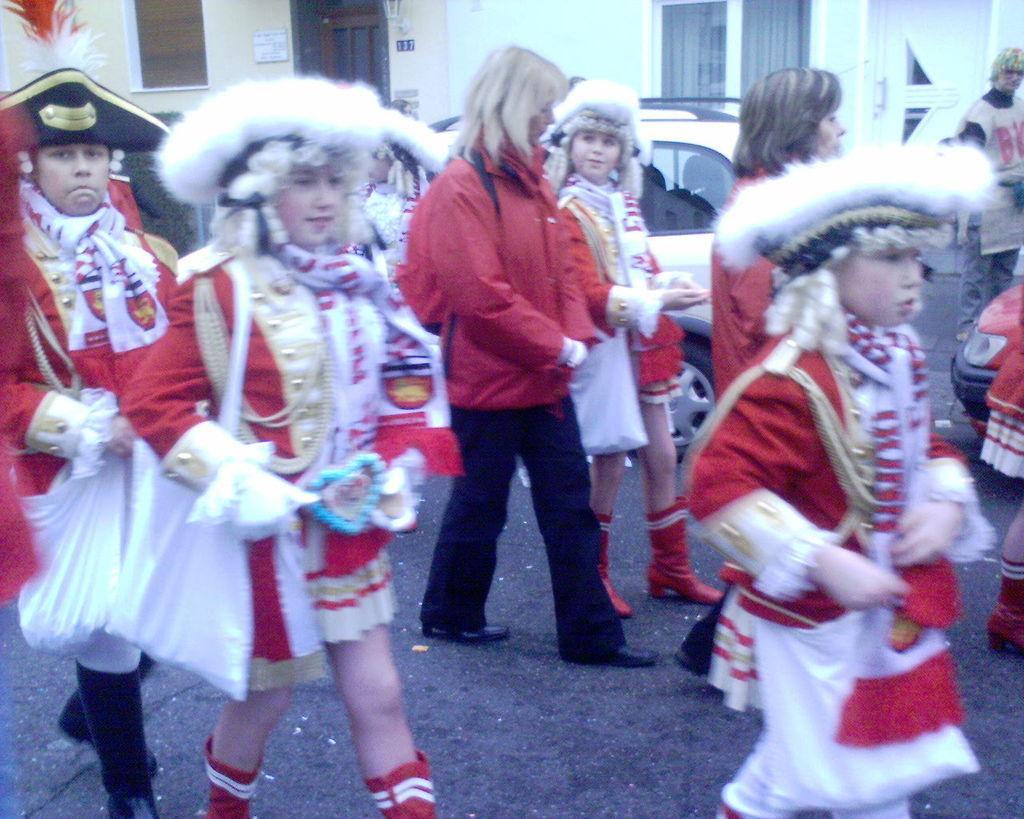Can you describe this image briefly? In this image, we can see people wearing costumes and walking. In the background, there are vehicles and buildings. At the bottom, there is road. 